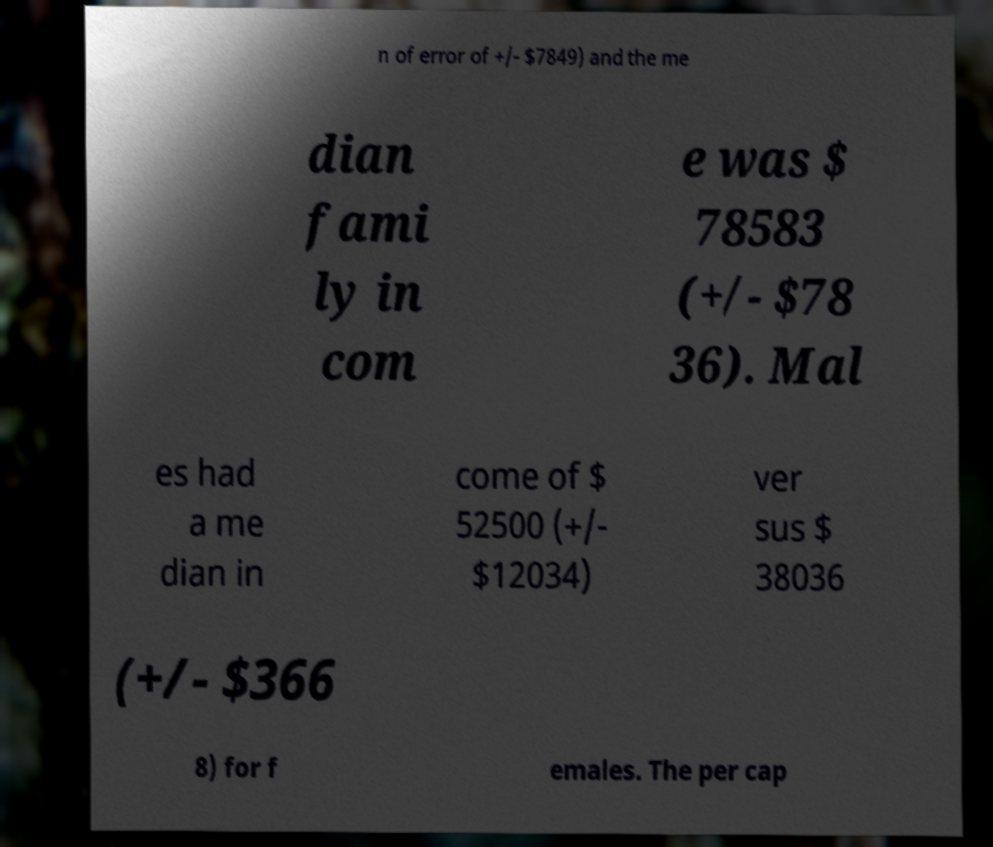Please identify and transcribe the text found in this image. n of error of +/- $7849) and the me dian fami ly in com e was $ 78583 (+/- $78 36). Mal es had a me dian in come of $ 52500 (+/- $12034) ver sus $ 38036 (+/- $366 8) for f emales. The per cap 